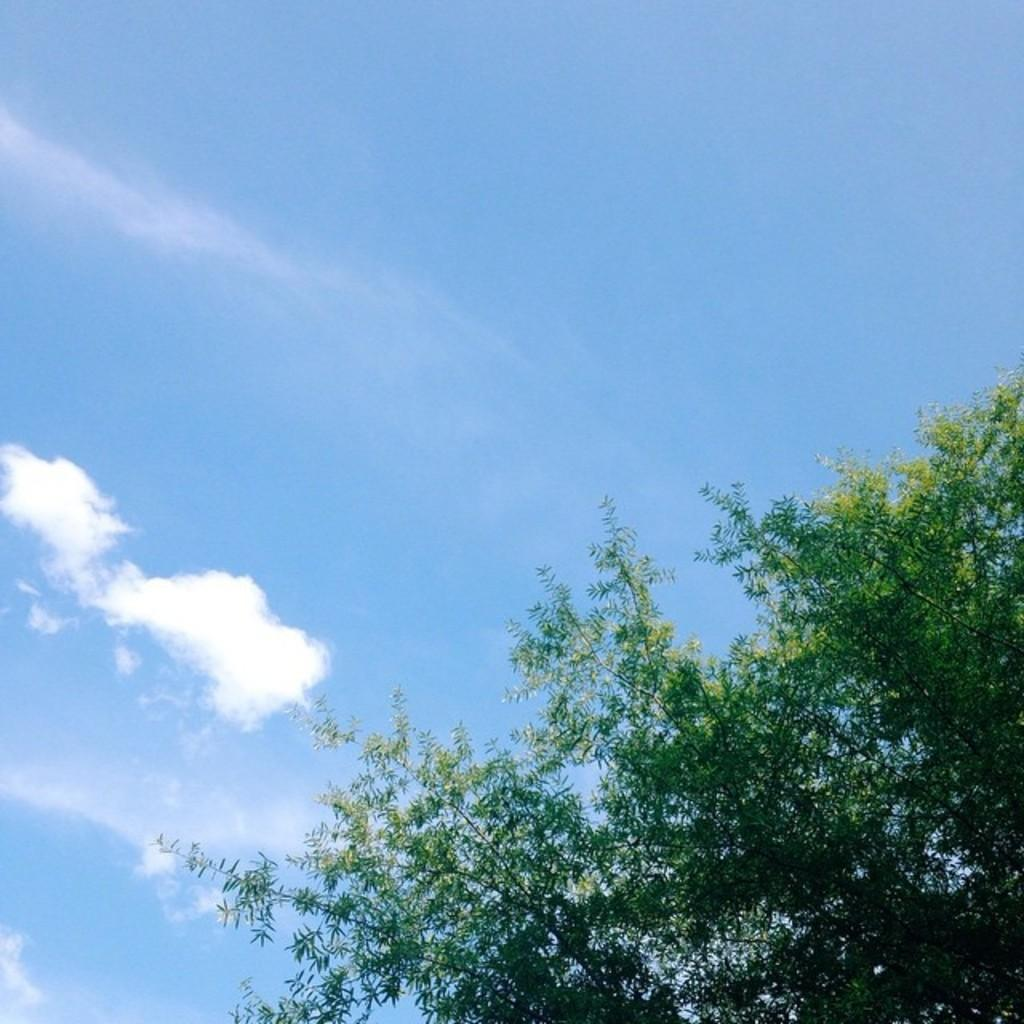What can be seen towards the right side of the image? There is a tree towards the right side of the image. What is visible in the image besides the tree? The sky is visible in the image. What can be observed in the sky? There are clouds in the sky. What is the color of the background in the image? The background of the image has a blue color. Where is the bell located in the image? There is no bell present in the image. What type of spark can be seen coming from the tree in the image? There is no spark visible in the image; it only shows a tree, sky, clouds, and a blue background. 